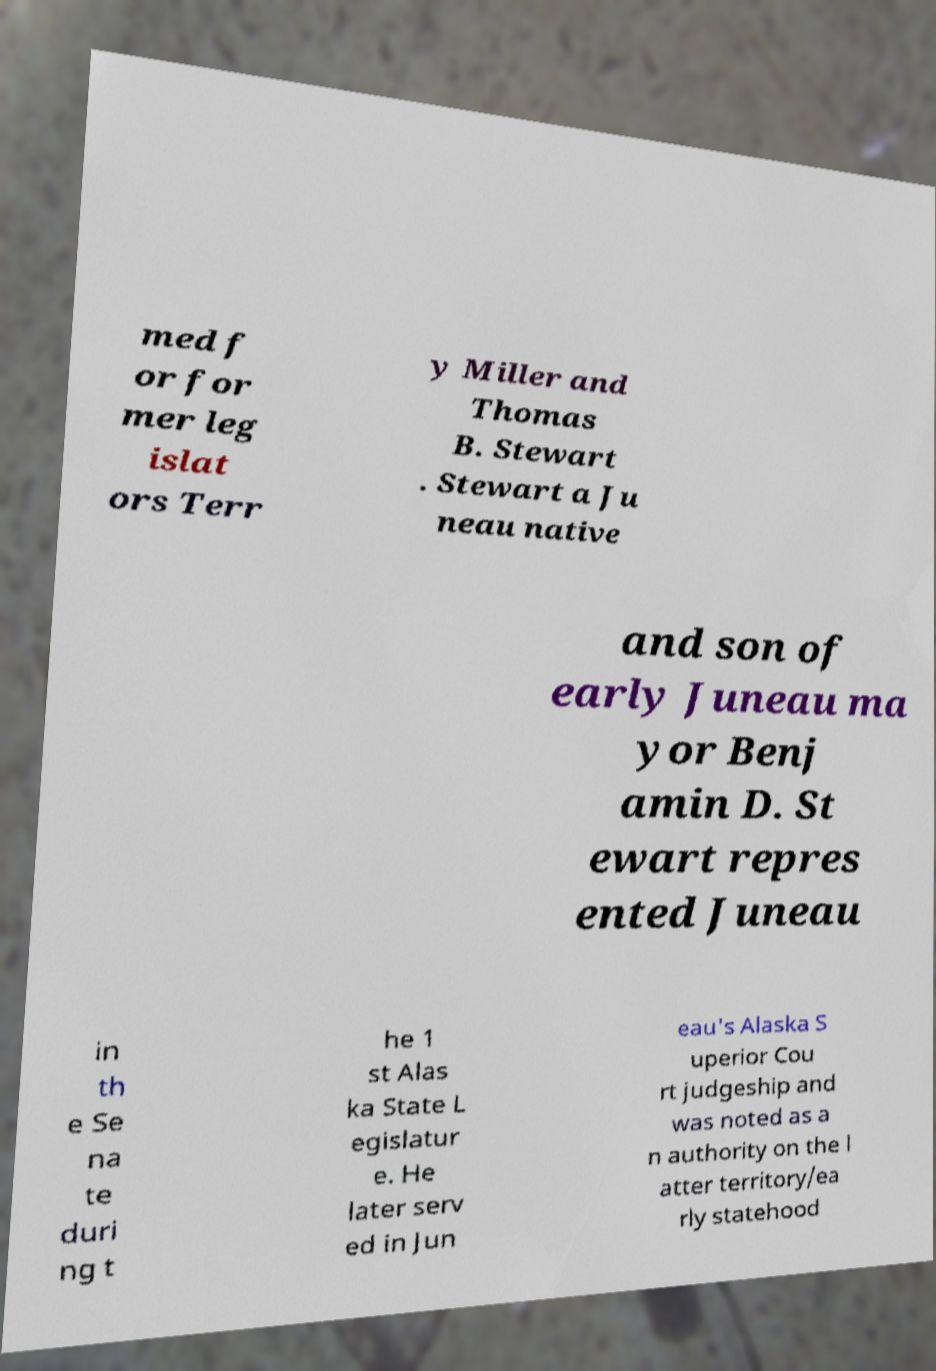Could you assist in decoding the text presented in this image and type it out clearly? med f or for mer leg islat ors Terr y Miller and Thomas B. Stewart . Stewart a Ju neau native and son of early Juneau ma yor Benj amin D. St ewart repres ented Juneau in th e Se na te duri ng t he 1 st Alas ka State L egislatur e. He later serv ed in Jun eau's Alaska S uperior Cou rt judgeship and was noted as a n authority on the l atter territory/ea rly statehood 